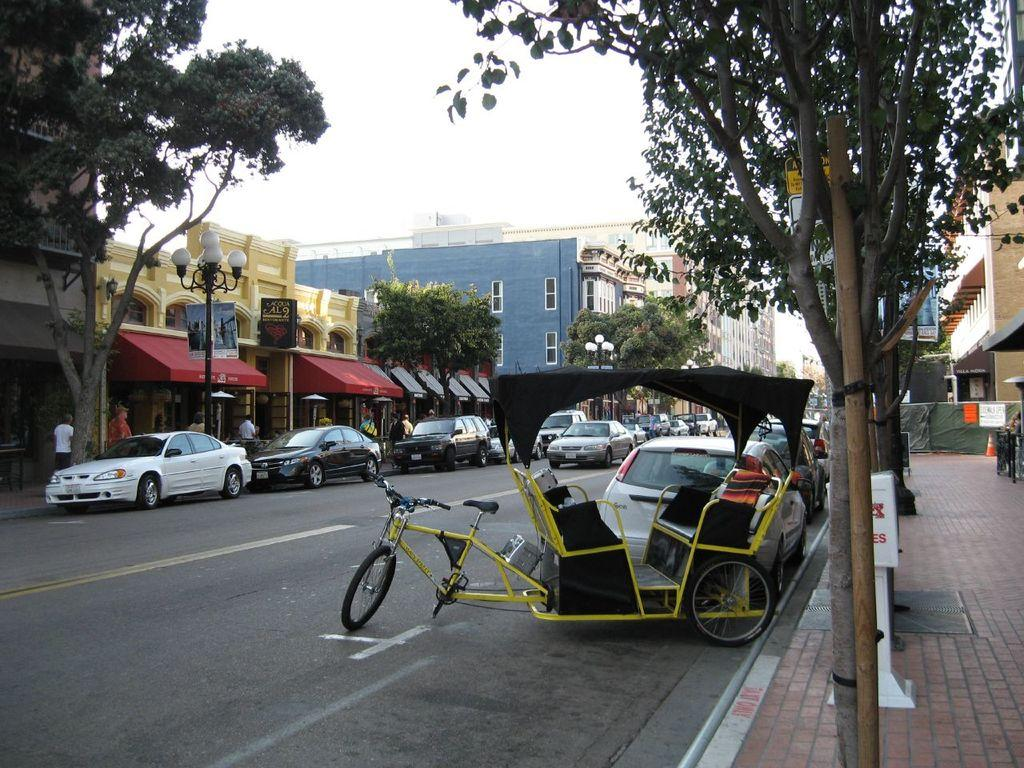What type of vehicles can be seen on the road in the image? There are cars and a rickshaw on the road in the image. What type of structures are visible in the image? There are buildings with windows in the image. What type of vegetation is present in the image? There are trees in the image. What type of infrastructure is present in the image? There are poles in the image. What type of path is visible in the image? There is a footpath in the image. Are there any people visible in the image? Yes, there are people in the image. What is visible in the background of the image? The sky is visible in the background of the image. What type of vegetable is being sold at the church in the image? There is no church or vegetable present in the image. What type of pets can be seen playing on the footpath in the image? There are no pets visible in the image. 